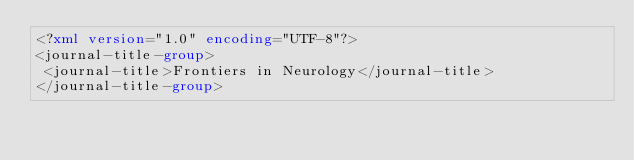<code> <loc_0><loc_0><loc_500><loc_500><_XML_><?xml version="1.0" encoding="UTF-8"?>
<journal-title-group>
 <journal-title>Frontiers in Neurology</journal-title>
</journal-title-group>
</code> 